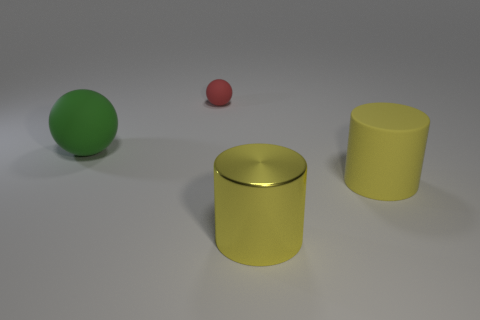Subtract all green spheres. Subtract all red cylinders. How many spheres are left? 1 Add 4 purple shiny spheres. How many objects exist? 8 Subtract all big rubber spheres. Subtract all yellow things. How many objects are left? 1 Add 4 yellow matte things. How many yellow matte things are left? 5 Add 2 large spheres. How many large spheres exist? 3 Subtract 0 purple balls. How many objects are left? 4 